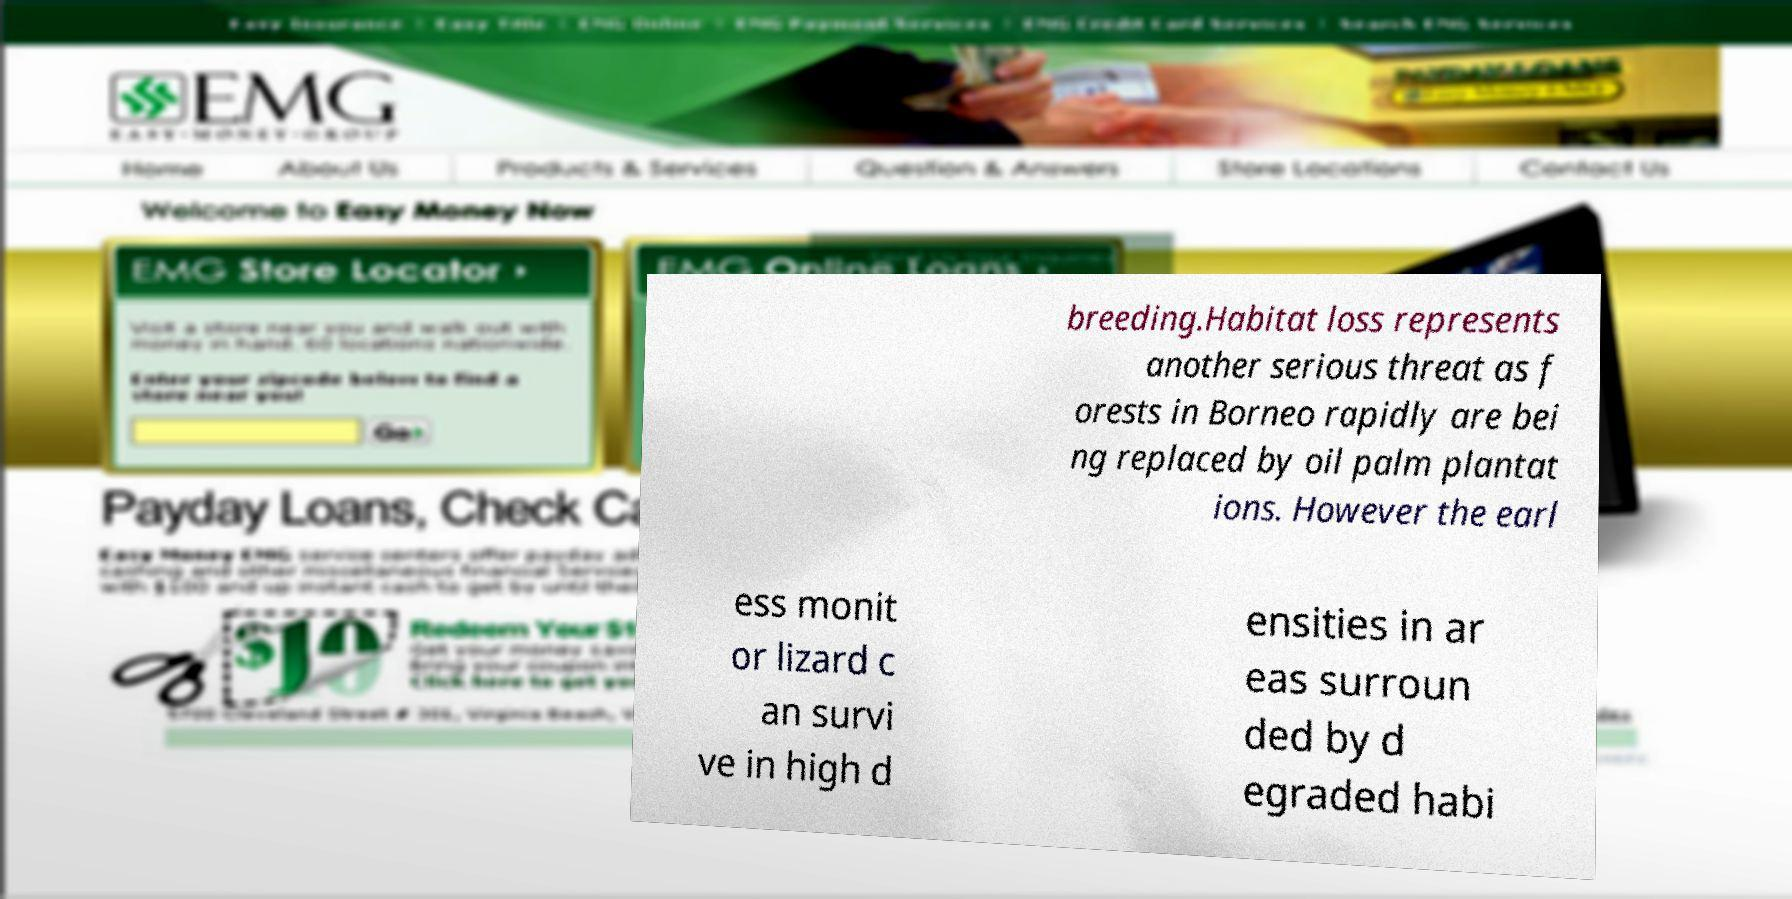Please read and relay the text visible in this image. What does it say? breeding.Habitat loss represents another serious threat as f orests in Borneo rapidly are bei ng replaced by oil palm plantat ions. However the earl ess monit or lizard c an survi ve in high d ensities in ar eas surroun ded by d egraded habi 